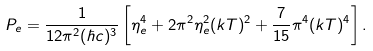Convert formula to latex. <formula><loc_0><loc_0><loc_500><loc_500>P _ { e } = \frac { 1 } { 1 2 \pi ^ { 2 } ( \hbar { c } ) ^ { 3 } } \left [ \eta _ { e } ^ { 4 } + 2 \pi ^ { 2 } \eta _ { e } ^ { 2 } ( k T ) ^ { 2 } + \frac { 7 } { 1 5 } \pi ^ { 4 } ( k T ) ^ { 4 } \right ] .</formula> 